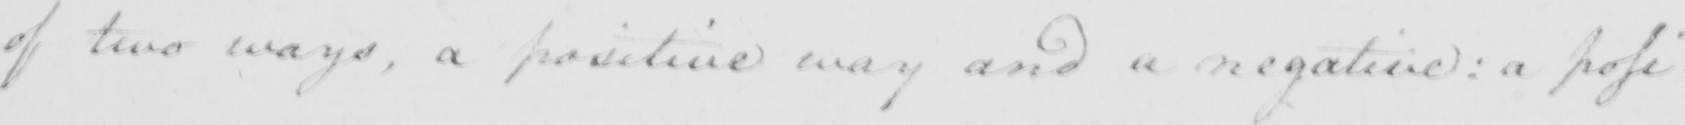Please transcribe the handwritten text in this image. of two ways , a positive way and a negative :  a posi : 